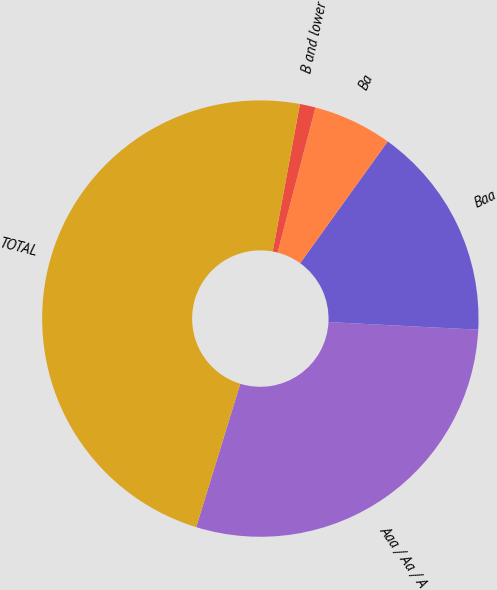Convert chart. <chart><loc_0><loc_0><loc_500><loc_500><pie_chart><fcel>Aaa / Aa / A<fcel>Baa<fcel>Ba<fcel>B and lower<fcel>TOTAL<nl><fcel>28.94%<fcel>15.89%<fcel>5.86%<fcel>1.16%<fcel>48.16%<nl></chart> 